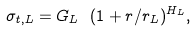<formula> <loc_0><loc_0><loc_500><loc_500>\sigma _ { t , L } = G _ { L } \ ( 1 + r / r _ { L } ) ^ { H _ { L } } ,</formula> 